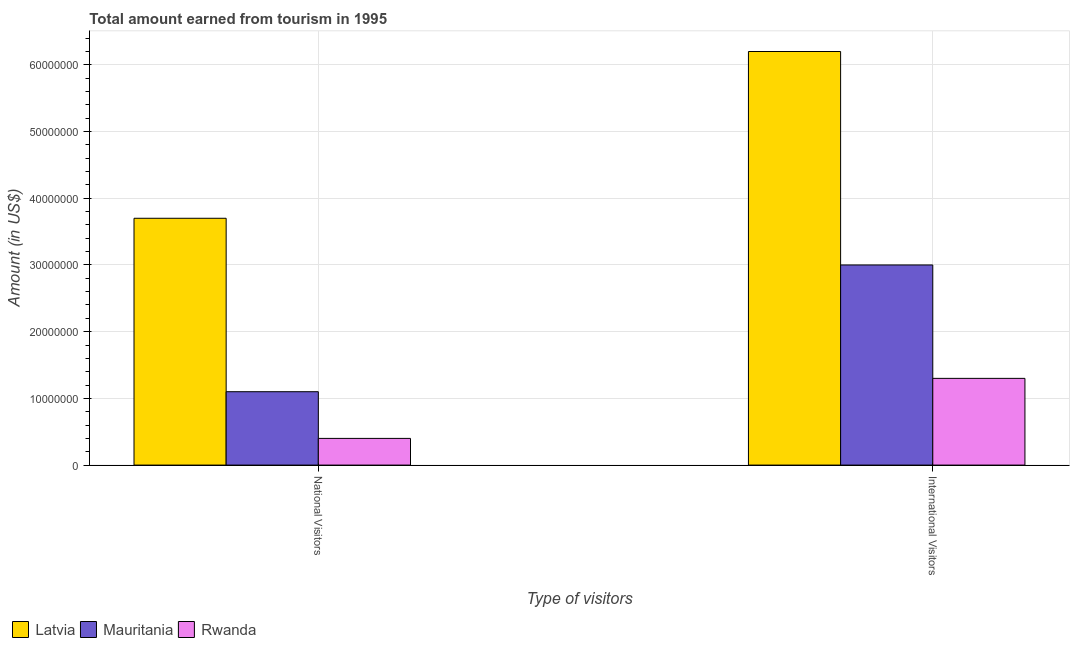How many groups of bars are there?
Give a very brief answer. 2. How many bars are there on the 2nd tick from the left?
Provide a succinct answer. 3. How many bars are there on the 2nd tick from the right?
Offer a very short reply. 3. What is the label of the 2nd group of bars from the left?
Provide a succinct answer. International Visitors. What is the amount earned from international visitors in Rwanda?
Provide a short and direct response. 1.30e+07. Across all countries, what is the maximum amount earned from national visitors?
Offer a terse response. 3.70e+07. Across all countries, what is the minimum amount earned from national visitors?
Offer a very short reply. 4.00e+06. In which country was the amount earned from national visitors maximum?
Your answer should be very brief. Latvia. In which country was the amount earned from national visitors minimum?
Keep it short and to the point. Rwanda. What is the total amount earned from national visitors in the graph?
Your answer should be compact. 5.20e+07. What is the difference between the amount earned from national visitors in Latvia and that in Mauritania?
Offer a terse response. 2.60e+07. What is the difference between the amount earned from national visitors in Rwanda and the amount earned from international visitors in Mauritania?
Your answer should be compact. -2.60e+07. What is the average amount earned from international visitors per country?
Your response must be concise. 3.50e+07. What is the difference between the amount earned from international visitors and amount earned from national visitors in Mauritania?
Your answer should be compact. 1.90e+07. What is the ratio of the amount earned from national visitors in Mauritania to that in Rwanda?
Offer a very short reply. 2.75. Is the amount earned from international visitors in Mauritania less than that in Rwanda?
Provide a succinct answer. No. What does the 3rd bar from the left in International Visitors represents?
Offer a very short reply. Rwanda. What does the 3rd bar from the right in National Visitors represents?
Your response must be concise. Latvia. How many countries are there in the graph?
Provide a short and direct response. 3. What is the difference between two consecutive major ticks on the Y-axis?
Offer a terse response. 1.00e+07. Does the graph contain any zero values?
Your response must be concise. No. Does the graph contain grids?
Your answer should be very brief. Yes. Where does the legend appear in the graph?
Your answer should be compact. Bottom left. What is the title of the graph?
Your answer should be very brief. Total amount earned from tourism in 1995. Does "Serbia" appear as one of the legend labels in the graph?
Give a very brief answer. No. What is the label or title of the X-axis?
Your answer should be very brief. Type of visitors. What is the label or title of the Y-axis?
Provide a succinct answer. Amount (in US$). What is the Amount (in US$) in Latvia in National Visitors?
Keep it short and to the point. 3.70e+07. What is the Amount (in US$) in Mauritania in National Visitors?
Give a very brief answer. 1.10e+07. What is the Amount (in US$) in Latvia in International Visitors?
Offer a very short reply. 6.20e+07. What is the Amount (in US$) in Mauritania in International Visitors?
Give a very brief answer. 3.00e+07. What is the Amount (in US$) in Rwanda in International Visitors?
Ensure brevity in your answer.  1.30e+07. Across all Type of visitors, what is the maximum Amount (in US$) in Latvia?
Your response must be concise. 6.20e+07. Across all Type of visitors, what is the maximum Amount (in US$) of Mauritania?
Offer a very short reply. 3.00e+07. Across all Type of visitors, what is the maximum Amount (in US$) of Rwanda?
Provide a succinct answer. 1.30e+07. Across all Type of visitors, what is the minimum Amount (in US$) in Latvia?
Give a very brief answer. 3.70e+07. Across all Type of visitors, what is the minimum Amount (in US$) in Mauritania?
Provide a short and direct response. 1.10e+07. What is the total Amount (in US$) of Latvia in the graph?
Ensure brevity in your answer.  9.90e+07. What is the total Amount (in US$) of Mauritania in the graph?
Your answer should be very brief. 4.10e+07. What is the total Amount (in US$) of Rwanda in the graph?
Ensure brevity in your answer.  1.70e+07. What is the difference between the Amount (in US$) of Latvia in National Visitors and that in International Visitors?
Provide a succinct answer. -2.50e+07. What is the difference between the Amount (in US$) in Mauritania in National Visitors and that in International Visitors?
Offer a terse response. -1.90e+07. What is the difference between the Amount (in US$) in Rwanda in National Visitors and that in International Visitors?
Offer a terse response. -9.00e+06. What is the difference between the Amount (in US$) of Latvia in National Visitors and the Amount (in US$) of Mauritania in International Visitors?
Ensure brevity in your answer.  7.00e+06. What is the difference between the Amount (in US$) in Latvia in National Visitors and the Amount (in US$) in Rwanda in International Visitors?
Your response must be concise. 2.40e+07. What is the average Amount (in US$) in Latvia per Type of visitors?
Give a very brief answer. 4.95e+07. What is the average Amount (in US$) in Mauritania per Type of visitors?
Keep it short and to the point. 2.05e+07. What is the average Amount (in US$) of Rwanda per Type of visitors?
Your answer should be compact. 8.50e+06. What is the difference between the Amount (in US$) in Latvia and Amount (in US$) in Mauritania in National Visitors?
Your response must be concise. 2.60e+07. What is the difference between the Amount (in US$) of Latvia and Amount (in US$) of Rwanda in National Visitors?
Offer a terse response. 3.30e+07. What is the difference between the Amount (in US$) of Mauritania and Amount (in US$) of Rwanda in National Visitors?
Provide a succinct answer. 7.00e+06. What is the difference between the Amount (in US$) in Latvia and Amount (in US$) in Mauritania in International Visitors?
Provide a short and direct response. 3.20e+07. What is the difference between the Amount (in US$) of Latvia and Amount (in US$) of Rwanda in International Visitors?
Provide a short and direct response. 4.90e+07. What is the difference between the Amount (in US$) of Mauritania and Amount (in US$) of Rwanda in International Visitors?
Your response must be concise. 1.70e+07. What is the ratio of the Amount (in US$) in Latvia in National Visitors to that in International Visitors?
Offer a very short reply. 0.6. What is the ratio of the Amount (in US$) of Mauritania in National Visitors to that in International Visitors?
Give a very brief answer. 0.37. What is the ratio of the Amount (in US$) of Rwanda in National Visitors to that in International Visitors?
Keep it short and to the point. 0.31. What is the difference between the highest and the second highest Amount (in US$) in Latvia?
Provide a succinct answer. 2.50e+07. What is the difference between the highest and the second highest Amount (in US$) in Mauritania?
Offer a very short reply. 1.90e+07. What is the difference between the highest and the second highest Amount (in US$) in Rwanda?
Your answer should be compact. 9.00e+06. What is the difference between the highest and the lowest Amount (in US$) in Latvia?
Make the answer very short. 2.50e+07. What is the difference between the highest and the lowest Amount (in US$) in Mauritania?
Give a very brief answer. 1.90e+07. What is the difference between the highest and the lowest Amount (in US$) of Rwanda?
Provide a succinct answer. 9.00e+06. 